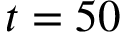<formula> <loc_0><loc_0><loc_500><loc_500>t = 5 0</formula> 